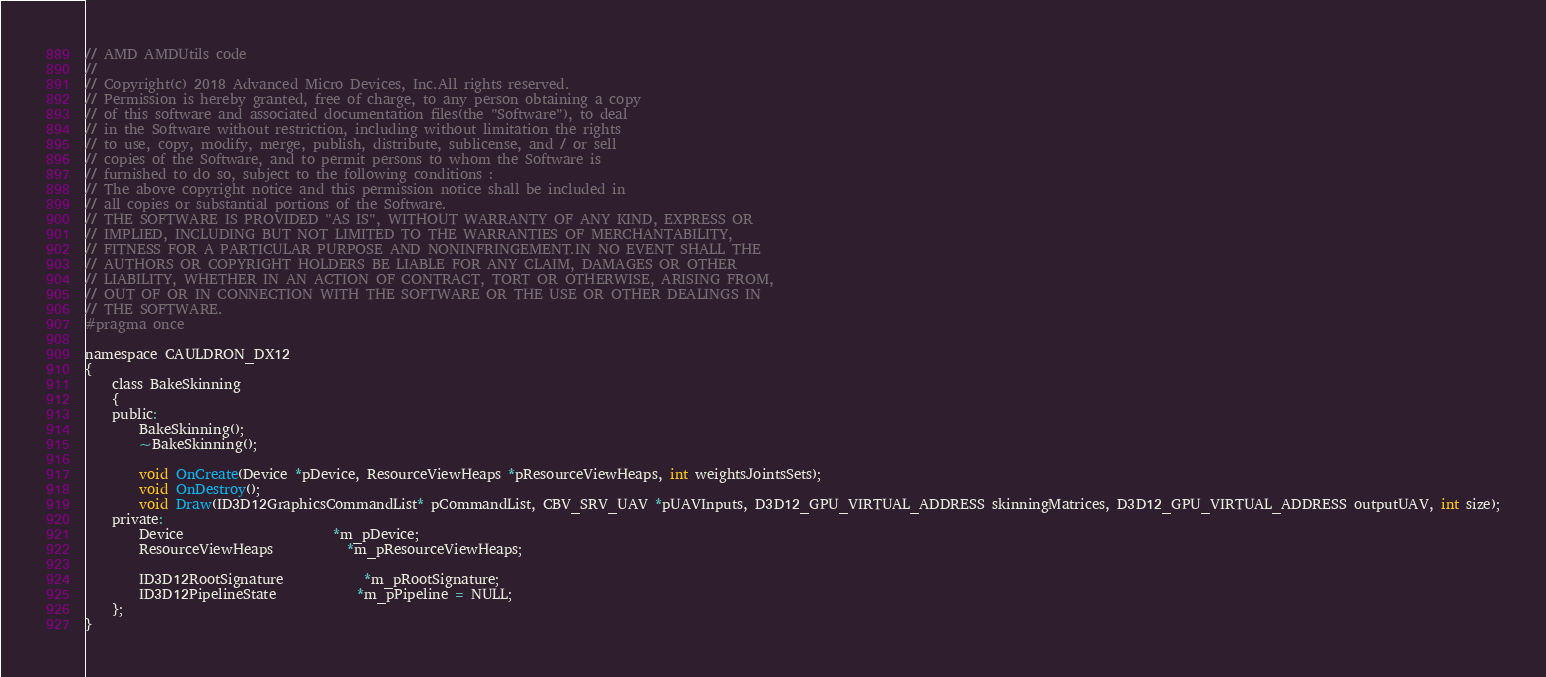<code> <loc_0><loc_0><loc_500><loc_500><_C_>// AMD AMDUtils code
// 
// Copyright(c) 2018 Advanced Micro Devices, Inc.All rights reserved.
// Permission is hereby granted, free of charge, to any person obtaining a copy
// of this software and associated documentation files(the "Software"), to deal
// in the Software without restriction, including without limitation the rights
// to use, copy, modify, merge, publish, distribute, sublicense, and / or sell
// copies of the Software, and to permit persons to whom the Software is
// furnished to do so, subject to the following conditions :
// The above copyright notice and this permission notice shall be included in
// all copies or substantial portions of the Software.
// THE SOFTWARE IS PROVIDED "AS IS", WITHOUT WARRANTY OF ANY KIND, EXPRESS OR
// IMPLIED, INCLUDING BUT NOT LIMITED TO THE WARRANTIES OF MERCHANTABILITY,
// FITNESS FOR A PARTICULAR PURPOSE AND NONINFRINGEMENT.IN NO EVENT SHALL THE
// AUTHORS OR COPYRIGHT HOLDERS BE LIABLE FOR ANY CLAIM, DAMAGES OR OTHER
// LIABILITY, WHETHER IN AN ACTION OF CONTRACT, TORT OR OTHERWISE, ARISING FROM,
// OUT OF OR IN CONNECTION WITH THE SOFTWARE OR THE USE OR OTHER DEALINGS IN
// THE SOFTWARE.
#pragma once

namespace CAULDRON_DX12
{
    class BakeSkinning
    {
    public:
        BakeSkinning();
        ~BakeSkinning();

        void OnCreate(Device *pDevice, ResourceViewHeaps *pResourceViewHeaps, int weightsJointsSets);
        void OnDestroy();
        void Draw(ID3D12GraphicsCommandList* pCommandList, CBV_SRV_UAV *pUAVInputs, D3D12_GPU_VIRTUAL_ADDRESS skinningMatrices, D3D12_GPU_VIRTUAL_ADDRESS outputUAV, int size);
    private:
        Device                      *m_pDevice;
        ResourceViewHeaps           *m_pResourceViewHeaps;

        ID3D12RootSignature	        *m_pRootSignature;
        ID3D12PipelineState	        *m_pPipeline = NULL;
    };
}
</code> 